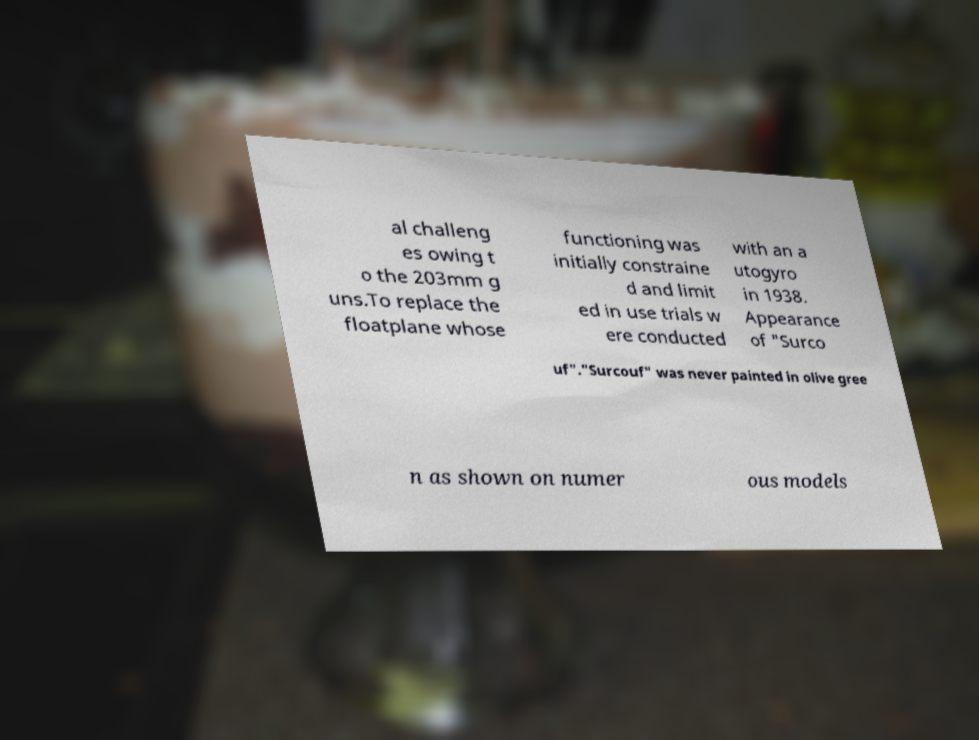Can you accurately transcribe the text from the provided image for me? al challeng es owing t o the 203mm g uns.To replace the floatplane whose functioning was initially constraine d and limit ed in use trials w ere conducted with an a utogyro in 1938. Appearance of "Surco uf"."Surcouf" was never painted in olive gree n as shown on numer ous models 